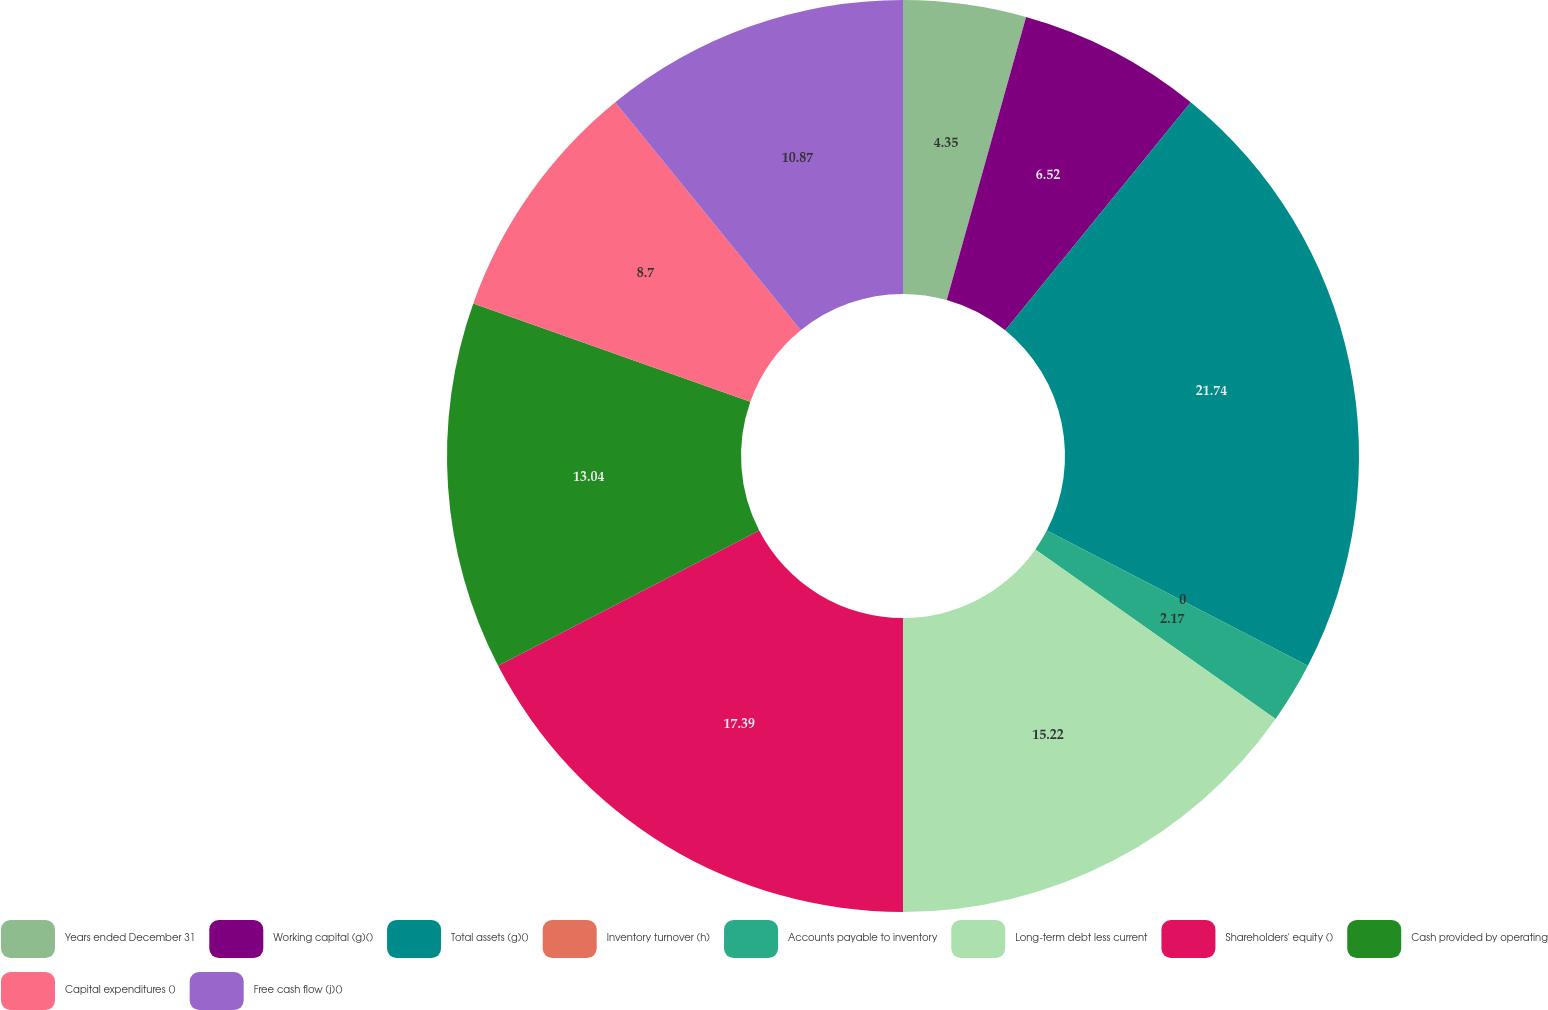Convert chart. <chart><loc_0><loc_0><loc_500><loc_500><pie_chart><fcel>Years ended December 31<fcel>Working capital (g)()<fcel>Total assets (g)()<fcel>Inventory turnover (h)<fcel>Accounts payable to inventory<fcel>Long-term debt less current<fcel>Shareholders' equity ()<fcel>Cash provided by operating<fcel>Capital expenditures ()<fcel>Free cash flow (j)()<nl><fcel>4.35%<fcel>6.52%<fcel>21.74%<fcel>0.0%<fcel>2.17%<fcel>15.22%<fcel>17.39%<fcel>13.04%<fcel>8.7%<fcel>10.87%<nl></chart> 